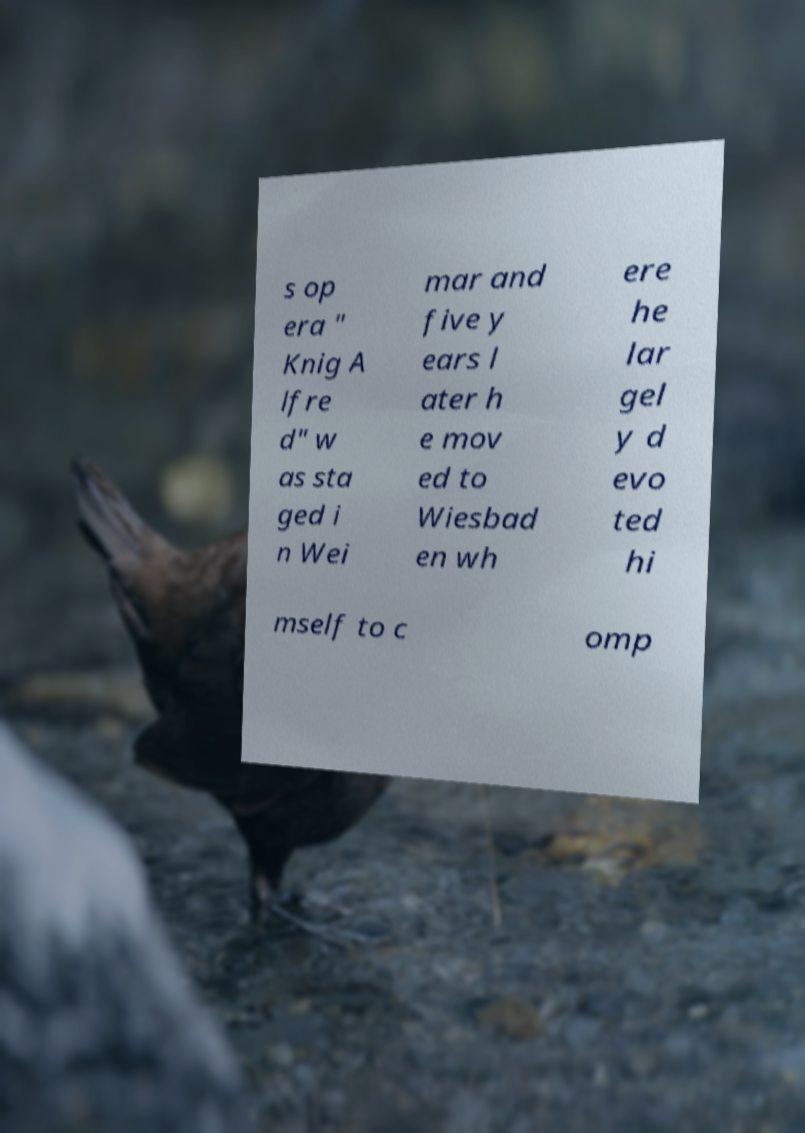For documentation purposes, I need the text within this image transcribed. Could you provide that? s op era " Knig A lfre d" w as sta ged i n Wei mar and five y ears l ater h e mov ed to Wiesbad en wh ere he lar gel y d evo ted hi mself to c omp 